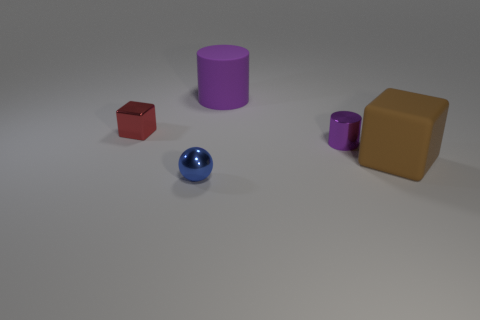What textures can you observe on the surfaces of the objects? The objects exhibit various textures: the sphere has a glossy finish reflecting light, the cubes have a matte, slightly textured surface, and the cylinder and the cup seem to have a rubber-like texture with no reflection. Are there any shadows visible, and what can they tell us about the light source? Yes, there are shadows cast to the right of the objects, indicating the light source is coming from the left side of the scene. The shadows are soft-edged, which suggests the light source is not too harsh. 